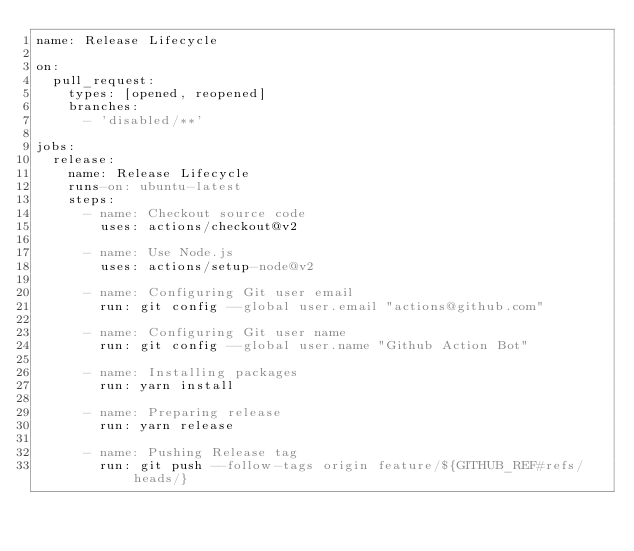Convert code to text. <code><loc_0><loc_0><loc_500><loc_500><_YAML_>name: Release Lifecycle

on:
  pull_request:
    types: [opened, reopened]
    branches:
      - 'disabled/**'

jobs:
  release:
    name: Release Lifecycle
    runs-on: ubuntu-latest
    steps:
      - name: Checkout source code
        uses: actions/checkout@v2

      - name: Use Node.js
        uses: actions/setup-node@v2

      - name: Configuring Git user email
        run: git config --global user.email "actions@github.com"

      - name: Configuring Git user name
        run: git config --global user.name "Github Action Bot"

      - name: Installing packages
        run: yarn install

      - name: Preparing release
        run: yarn release

      - name: Pushing Release tag
        run: git push --follow-tags origin feature/${GITHUB_REF#refs/heads/}
</code> 